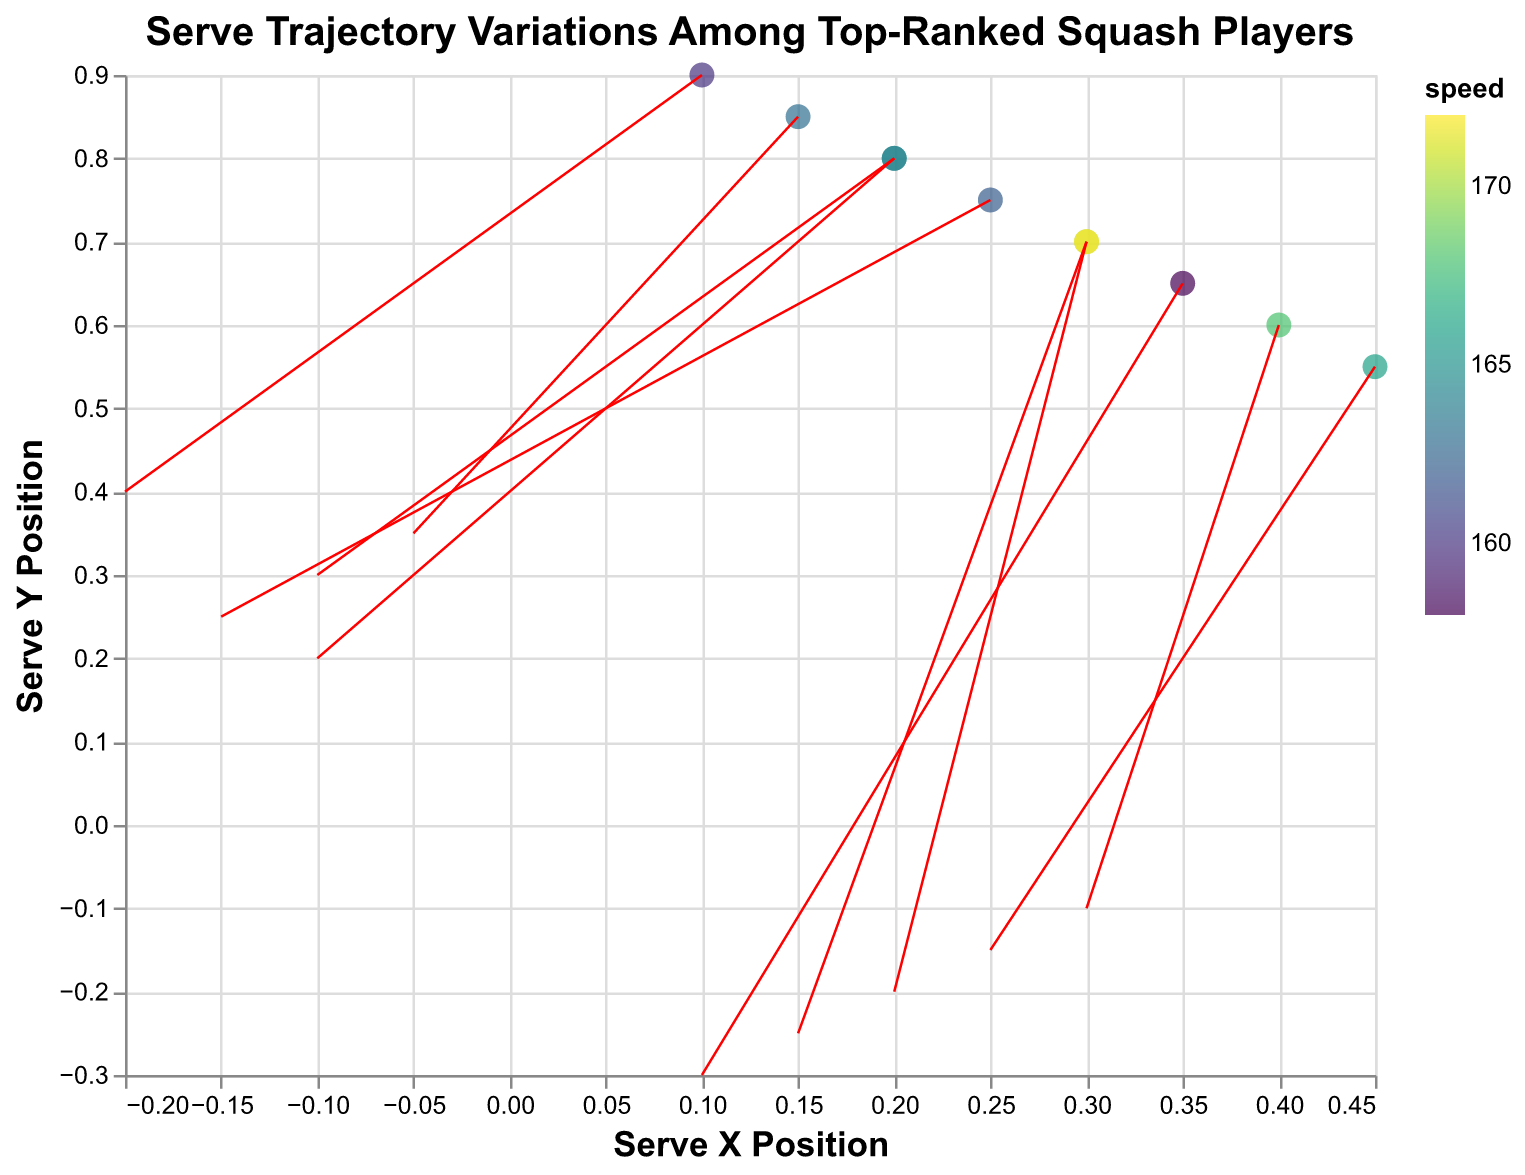What's the title of the plot? The title is displayed at the top of the plot. It reads: "Serve Trajectory Variations Among Top-Ranked Squash Players".
Answer: Serve Trajectory Variations Among Top-Ranked Squash Players What are the axis labels? The x-axis is labeled "Serve X Position" and the y-axis is labeled "Serve Y Position". These are mentioned along the corresponding axes of the plot.
Answer: Serve X Position, Serve Y Position Which player has the highest serve speed? By looking at the color gradient based on speed, the player with the highest speed value is shown as Mostafa Asal with a speed of 172. This is indicated by the tooltip and the darkest color among the points.
Answer: Mostafa Asal What is the serve speed of Ali Farag and Diego Elias? Ali Farag's speed can be seen in the tooltip when hovering over his point, which shows a speed of 165. Similarly, Diego Elias's tooltip shows a speed of 168.
Answer: Ali Farag: 165, Diego Elias: 168 Compare the spin values of Paul Coll and Marwan ElShorbagy. Which one has the greater spin_x value and which has the greater spin_y value? Paul Coll has a spin_x value of -0.2 and a spin_y value of 0.4. Marwan ElShorbagy has a spin_x value of -0.05 and a spin_y value of 0.35. Comparing these values, Marwan ElShorbagy has a greater spin_x value, while Paul Coll has a greater spin_y value.
Answer: spin_x: Marwan ElShorbagy, spin_y: Paul Coll What is the average serve speed of all the players? Sum up the serve speeds of all players: 165+170+160+168+162+158+163+166+172+164 = 1648. There are 10 players, so the average speed is 1648/10 = 164.8
Answer: 164.8 Which player has the serve located closest to the serve_x = 0.3 and serve_y = 0.7 coordinate? Both Mohamed ElShorbagy and Mostafa Asal have serves located exactly at serve_x = 0.3 and serve_y = 0.7.
Answer: Mohamed ElShorbagy, Mostafa Asal Identify the player who has the serve_x position of 0.45. What is their serve_y position and speed? The player with serve_x of 0.45 is Karim Abdel Gawad. By checking the corresponding data, his serve_y position is 0.55 and his speed is 166.
Answer: serve_y: 0.55, speed: 166 Which player has the lowest serve speed and what is their spin_y value? The player with the lowest serve speed is Joel Makin with a speed of 158. His spin_y value, which is displayed from the same tooltip, is -0.3.
Answer: Joel Makin, spin_y: -0.3 